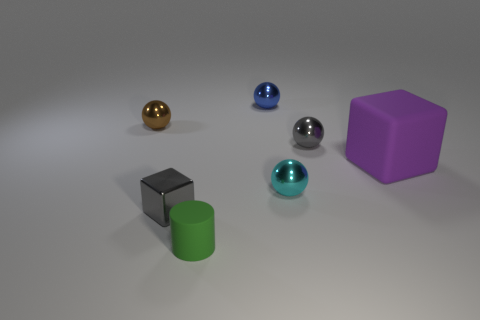Add 3 large gray objects. How many objects exist? 10 Subtract all brown balls. How many balls are left? 3 Subtract all cyan shiny spheres. How many spheres are left? 3 Subtract 0 gray cylinders. How many objects are left? 7 Subtract all cylinders. How many objects are left? 6 Subtract all red spheres. Subtract all cyan cubes. How many spheres are left? 4 Subtract all brown cubes. How many gray spheres are left? 1 Subtract all balls. Subtract all purple cubes. How many objects are left? 2 Add 7 big blocks. How many big blocks are left? 8 Add 4 large gray matte balls. How many large gray matte balls exist? 4 